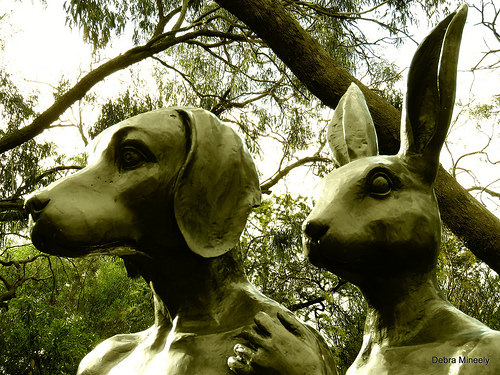<image>
Is there a dog to the right of the tree? Yes. From this viewpoint, the dog is positioned to the right side relative to the tree. Is the dog statue in front of the rabbit statue? No. The dog statue is not in front of the rabbit statue. The spatial positioning shows a different relationship between these objects. Is there a bunny in front of the dog? No. The bunny is not in front of the dog. The spatial positioning shows a different relationship between these objects. 